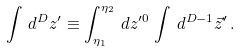<formula> <loc_0><loc_0><loc_500><loc_500>\int \, d ^ { D } z ^ { \prime } \equiv \int _ { \eta _ { 1 } } ^ { \eta _ { 2 } } \, d z ^ { \prime 0 } \, \int \, d ^ { D - 1 } \vec { z } ^ { \prime } \, .</formula> 